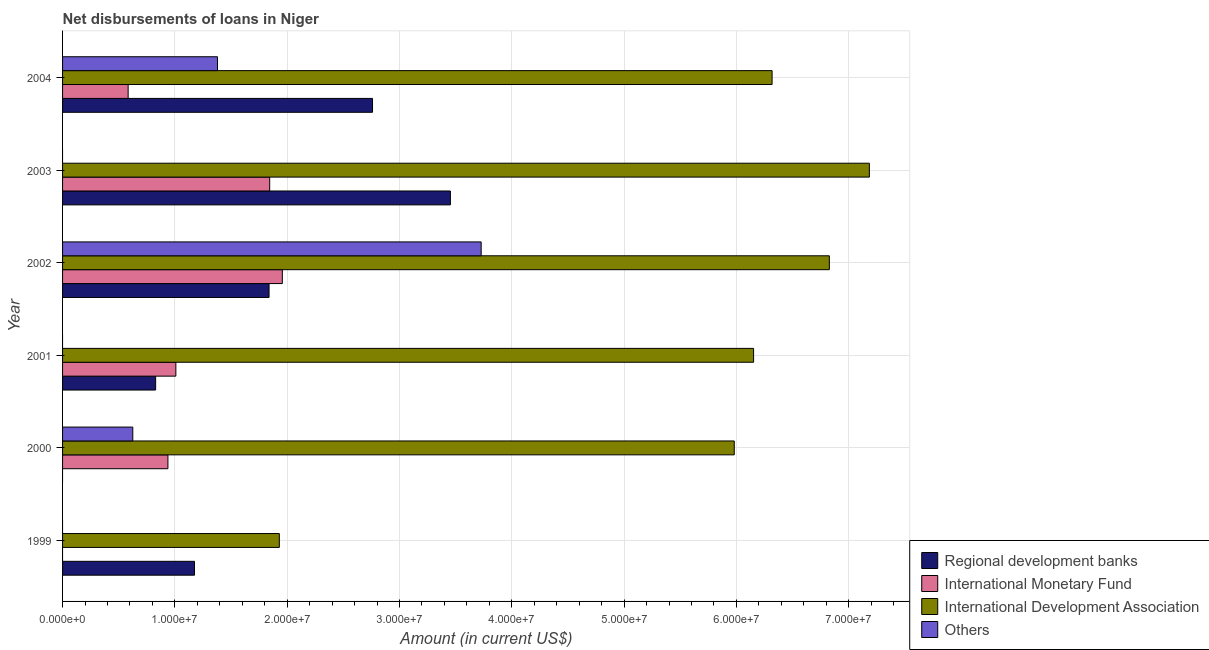How many different coloured bars are there?
Keep it short and to the point. 4. Are the number of bars on each tick of the Y-axis equal?
Your answer should be very brief. No. How many bars are there on the 2nd tick from the bottom?
Your answer should be compact. 3. What is the amount of loan disimbursed by regional development banks in 2004?
Offer a terse response. 2.76e+07. Across all years, what is the maximum amount of loan disimbursed by regional development banks?
Ensure brevity in your answer.  3.45e+07. Across all years, what is the minimum amount of loan disimbursed by regional development banks?
Provide a succinct answer. 0. What is the total amount of loan disimbursed by international development association in the graph?
Keep it short and to the point. 3.44e+08. What is the difference between the amount of loan disimbursed by international development association in 1999 and that in 2002?
Make the answer very short. -4.90e+07. What is the difference between the amount of loan disimbursed by regional development banks in 2000 and the amount of loan disimbursed by international development association in 2002?
Provide a succinct answer. -6.83e+07. What is the average amount of loan disimbursed by regional development banks per year?
Ensure brevity in your answer.  1.68e+07. In the year 2002, what is the difference between the amount of loan disimbursed by international monetary fund and amount of loan disimbursed by regional development banks?
Ensure brevity in your answer.  1.18e+06. What is the ratio of the amount of loan disimbursed by regional development banks in 2001 to that in 2002?
Your response must be concise. 0.45. Is the amount of loan disimbursed by regional development banks in 2001 less than that in 2003?
Offer a very short reply. Yes. What is the difference between the highest and the second highest amount of loan disimbursed by international monetary fund?
Your answer should be compact. 1.12e+06. What is the difference between the highest and the lowest amount of loan disimbursed by regional development banks?
Provide a succinct answer. 3.45e+07. Is it the case that in every year, the sum of the amount of loan disimbursed by international development association and amount of loan disimbursed by regional development banks is greater than the sum of amount of loan disimbursed by international monetary fund and amount of loan disimbursed by other organisations?
Keep it short and to the point. No. Is it the case that in every year, the sum of the amount of loan disimbursed by regional development banks and amount of loan disimbursed by international monetary fund is greater than the amount of loan disimbursed by international development association?
Your answer should be compact. No. How many years are there in the graph?
Offer a very short reply. 6. What is the difference between two consecutive major ticks on the X-axis?
Your response must be concise. 1.00e+07. Does the graph contain grids?
Offer a very short reply. Yes. Where does the legend appear in the graph?
Your response must be concise. Bottom right. How many legend labels are there?
Your response must be concise. 4. What is the title of the graph?
Your answer should be compact. Net disbursements of loans in Niger. Does "Third 20% of population" appear as one of the legend labels in the graph?
Keep it short and to the point. No. What is the label or title of the Y-axis?
Your answer should be very brief. Year. What is the Amount (in current US$) in Regional development banks in 1999?
Offer a very short reply. 1.17e+07. What is the Amount (in current US$) in International Development Association in 1999?
Provide a succinct answer. 1.93e+07. What is the Amount (in current US$) in Others in 1999?
Provide a succinct answer. 0. What is the Amount (in current US$) of Regional development banks in 2000?
Keep it short and to the point. 0. What is the Amount (in current US$) of International Monetary Fund in 2000?
Your response must be concise. 9.38e+06. What is the Amount (in current US$) of International Development Association in 2000?
Give a very brief answer. 5.98e+07. What is the Amount (in current US$) in Others in 2000?
Your answer should be compact. 6.25e+06. What is the Amount (in current US$) of Regional development banks in 2001?
Your answer should be very brief. 8.29e+06. What is the Amount (in current US$) of International Monetary Fund in 2001?
Your response must be concise. 1.01e+07. What is the Amount (in current US$) in International Development Association in 2001?
Offer a terse response. 6.15e+07. What is the Amount (in current US$) of Others in 2001?
Provide a short and direct response. 0. What is the Amount (in current US$) of Regional development banks in 2002?
Provide a short and direct response. 1.84e+07. What is the Amount (in current US$) in International Monetary Fund in 2002?
Your answer should be very brief. 1.96e+07. What is the Amount (in current US$) in International Development Association in 2002?
Offer a terse response. 6.83e+07. What is the Amount (in current US$) in Others in 2002?
Your answer should be compact. 3.73e+07. What is the Amount (in current US$) in Regional development banks in 2003?
Your response must be concise. 3.45e+07. What is the Amount (in current US$) of International Monetary Fund in 2003?
Your response must be concise. 1.84e+07. What is the Amount (in current US$) in International Development Association in 2003?
Give a very brief answer. 7.18e+07. What is the Amount (in current US$) in Regional development banks in 2004?
Offer a very short reply. 2.76e+07. What is the Amount (in current US$) of International Monetary Fund in 2004?
Offer a terse response. 5.84e+06. What is the Amount (in current US$) of International Development Association in 2004?
Provide a short and direct response. 6.32e+07. What is the Amount (in current US$) in Others in 2004?
Provide a succinct answer. 1.38e+07. Across all years, what is the maximum Amount (in current US$) in Regional development banks?
Make the answer very short. 3.45e+07. Across all years, what is the maximum Amount (in current US$) of International Monetary Fund?
Provide a succinct answer. 1.96e+07. Across all years, what is the maximum Amount (in current US$) of International Development Association?
Offer a very short reply. 7.18e+07. Across all years, what is the maximum Amount (in current US$) in Others?
Ensure brevity in your answer.  3.73e+07. Across all years, what is the minimum Amount (in current US$) of Regional development banks?
Give a very brief answer. 0. Across all years, what is the minimum Amount (in current US$) in International Development Association?
Ensure brevity in your answer.  1.93e+07. Across all years, what is the minimum Amount (in current US$) of Others?
Provide a short and direct response. 0. What is the total Amount (in current US$) of Regional development banks in the graph?
Offer a very short reply. 1.01e+08. What is the total Amount (in current US$) of International Monetary Fund in the graph?
Your answer should be very brief. 6.33e+07. What is the total Amount (in current US$) in International Development Association in the graph?
Provide a short and direct response. 3.44e+08. What is the total Amount (in current US$) in Others in the graph?
Your answer should be very brief. 5.73e+07. What is the difference between the Amount (in current US$) in International Development Association in 1999 and that in 2000?
Ensure brevity in your answer.  -4.05e+07. What is the difference between the Amount (in current US$) in Regional development banks in 1999 and that in 2001?
Give a very brief answer. 3.46e+06. What is the difference between the Amount (in current US$) in International Development Association in 1999 and that in 2001?
Your answer should be compact. -4.22e+07. What is the difference between the Amount (in current US$) in Regional development banks in 1999 and that in 2002?
Your answer should be very brief. -6.64e+06. What is the difference between the Amount (in current US$) in International Development Association in 1999 and that in 2002?
Your answer should be very brief. -4.90e+07. What is the difference between the Amount (in current US$) of Regional development banks in 1999 and that in 2003?
Make the answer very short. -2.28e+07. What is the difference between the Amount (in current US$) in International Development Association in 1999 and that in 2003?
Offer a very short reply. -5.25e+07. What is the difference between the Amount (in current US$) of Regional development banks in 1999 and that in 2004?
Your response must be concise. -1.58e+07. What is the difference between the Amount (in current US$) of International Development Association in 1999 and that in 2004?
Make the answer very short. -4.39e+07. What is the difference between the Amount (in current US$) of International Monetary Fund in 2000 and that in 2001?
Your answer should be compact. -7.07e+05. What is the difference between the Amount (in current US$) of International Development Association in 2000 and that in 2001?
Give a very brief answer. -1.72e+06. What is the difference between the Amount (in current US$) of International Monetary Fund in 2000 and that in 2002?
Your response must be concise. -1.02e+07. What is the difference between the Amount (in current US$) in International Development Association in 2000 and that in 2002?
Offer a very short reply. -8.47e+06. What is the difference between the Amount (in current US$) in Others in 2000 and that in 2002?
Your answer should be very brief. -3.10e+07. What is the difference between the Amount (in current US$) of International Monetary Fund in 2000 and that in 2003?
Provide a short and direct response. -9.06e+06. What is the difference between the Amount (in current US$) of International Development Association in 2000 and that in 2003?
Your answer should be very brief. -1.20e+07. What is the difference between the Amount (in current US$) in International Monetary Fund in 2000 and that in 2004?
Keep it short and to the point. 3.54e+06. What is the difference between the Amount (in current US$) of International Development Association in 2000 and that in 2004?
Provide a short and direct response. -3.37e+06. What is the difference between the Amount (in current US$) in Others in 2000 and that in 2004?
Offer a terse response. -7.54e+06. What is the difference between the Amount (in current US$) of Regional development banks in 2001 and that in 2002?
Provide a short and direct response. -1.01e+07. What is the difference between the Amount (in current US$) in International Monetary Fund in 2001 and that in 2002?
Offer a very short reply. -9.48e+06. What is the difference between the Amount (in current US$) in International Development Association in 2001 and that in 2002?
Your answer should be very brief. -6.75e+06. What is the difference between the Amount (in current US$) of Regional development banks in 2001 and that in 2003?
Your answer should be very brief. -2.62e+07. What is the difference between the Amount (in current US$) of International Monetary Fund in 2001 and that in 2003?
Offer a very short reply. -8.36e+06. What is the difference between the Amount (in current US$) of International Development Association in 2001 and that in 2003?
Keep it short and to the point. -1.03e+07. What is the difference between the Amount (in current US$) of Regional development banks in 2001 and that in 2004?
Your response must be concise. -1.93e+07. What is the difference between the Amount (in current US$) in International Monetary Fund in 2001 and that in 2004?
Provide a short and direct response. 4.25e+06. What is the difference between the Amount (in current US$) of International Development Association in 2001 and that in 2004?
Your response must be concise. -1.65e+06. What is the difference between the Amount (in current US$) in Regional development banks in 2002 and that in 2003?
Your answer should be very brief. -1.61e+07. What is the difference between the Amount (in current US$) in International Monetary Fund in 2002 and that in 2003?
Offer a very short reply. 1.12e+06. What is the difference between the Amount (in current US$) in International Development Association in 2002 and that in 2003?
Offer a very short reply. -3.56e+06. What is the difference between the Amount (in current US$) of Regional development banks in 2002 and that in 2004?
Offer a very short reply. -9.21e+06. What is the difference between the Amount (in current US$) in International Monetary Fund in 2002 and that in 2004?
Ensure brevity in your answer.  1.37e+07. What is the difference between the Amount (in current US$) in International Development Association in 2002 and that in 2004?
Give a very brief answer. 5.10e+06. What is the difference between the Amount (in current US$) in Others in 2002 and that in 2004?
Give a very brief answer. 2.35e+07. What is the difference between the Amount (in current US$) of Regional development banks in 2003 and that in 2004?
Your answer should be compact. 6.94e+06. What is the difference between the Amount (in current US$) of International Monetary Fund in 2003 and that in 2004?
Provide a short and direct response. 1.26e+07. What is the difference between the Amount (in current US$) in International Development Association in 2003 and that in 2004?
Offer a very short reply. 8.66e+06. What is the difference between the Amount (in current US$) of Regional development banks in 1999 and the Amount (in current US$) of International Monetary Fund in 2000?
Keep it short and to the point. 2.37e+06. What is the difference between the Amount (in current US$) of Regional development banks in 1999 and the Amount (in current US$) of International Development Association in 2000?
Ensure brevity in your answer.  -4.81e+07. What is the difference between the Amount (in current US$) of Regional development banks in 1999 and the Amount (in current US$) of Others in 2000?
Offer a very short reply. 5.50e+06. What is the difference between the Amount (in current US$) of International Development Association in 1999 and the Amount (in current US$) of Others in 2000?
Offer a very short reply. 1.30e+07. What is the difference between the Amount (in current US$) in Regional development banks in 1999 and the Amount (in current US$) in International Monetary Fund in 2001?
Ensure brevity in your answer.  1.66e+06. What is the difference between the Amount (in current US$) in Regional development banks in 1999 and the Amount (in current US$) in International Development Association in 2001?
Your response must be concise. -4.98e+07. What is the difference between the Amount (in current US$) in Regional development banks in 1999 and the Amount (in current US$) in International Monetary Fund in 2002?
Give a very brief answer. -7.82e+06. What is the difference between the Amount (in current US$) of Regional development banks in 1999 and the Amount (in current US$) of International Development Association in 2002?
Give a very brief answer. -5.65e+07. What is the difference between the Amount (in current US$) in Regional development banks in 1999 and the Amount (in current US$) in Others in 2002?
Provide a short and direct response. -2.55e+07. What is the difference between the Amount (in current US$) of International Development Association in 1999 and the Amount (in current US$) of Others in 2002?
Give a very brief answer. -1.80e+07. What is the difference between the Amount (in current US$) of Regional development banks in 1999 and the Amount (in current US$) of International Monetary Fund in 2003?
Offer a terse response. -6.70e+06. What is the difference between the Amount (in current US$) of Regional development banks in 1999 and the Amount (in current US$) of International Development Association in 2003?
Ensure brevity in your answer.  -6.01e+07. What is the difference between the Amount (in current US$) of Regional development banks in 1999 and the Amount (in current US$) of International Monetary Fund in 2004?
Keep it short and to the point. 5.91e+06. What is the difference between the Amount (in current US$) in Regional development banks in 1999 and the Amount (in current US$) in International Development Association in 2004?
Provide a succinct answer. -5.14e+07. What is the difference between the Amount (in current US$) of Regional development banks in 1999 and the Amount (in current US$) of Others in 2004?
Offer a very short reply. -2.05e+06. What is the difference between the Amount (in current US$) of International Development Association in 1999 and the Amount (in current US$) of Others in 2004?
Your answer should be compact. 5.50e+06. What is the difference between the Amount (in current US$) in International Monetary Fund in 2000 and the Amount (in current US$) in International Development Association in 2001?
Provide a short and direct response. -5.21e+07. What is the difference between the Amount (in current US$) in International Monetary Fund in 2000 and the Amount (in current US$) in International Development Association in 2002?
Provide a short and direct response. -5.89e+07. What is the difference between the Amount (in current US$) of International Monetary Fund in 2000 and the Amount (in current US$) of Others in 2002?
Make the answer very short. -2.79e+07. What is the difference between the Amount (in current US$) in International Development Association in 2000 and the Amount (in current US$) in Others in 2002?
Offer a terse response. 2.25e+07. What is the difference between the Amount (in current US$) in International Monetary Fund in 2000 and the Amount (in current US$) in International Development Association in 2003?
Make the answer very short. -6.25e+07. What is the difference between the Amount (in current US$) of International Monetary Fund in 2000 and the Amount (in current US$) of International Development Association in 2004?
Ensure brevity in your answer.  -5.38e+07. What is the difference between the Amount (in current US$) in International Monetary Fund in 2000 and the Amount (in current US$) in Others in 2004?
Provide a succinct answer. -4.42e+06. What is the difference between the Amount (in current US$) in International Development Association in 2000 and the Amount (in current US$) in Others in 2004?
Provide a succinct answer. 4.60e+07. What is the difference between the Amount (in current US$) in Regional development banks in 2001 and the Amount (in current US$) in International Monetary Fund in 2002?
Keep it short and to the point. -1.13e+07. What is the difference between the Amount (in current US$) of Regional development banks in 2001 and the Amount (in current US$) of International Development Association in 2002?
Provide a succinct answer. -6.00e+07. What is the difference between the Amount (in current US$) in Regional development banks in 2001 and the Amount (in current US$) in Others in 2002?
Provide a short and direct response. -2.90e+07. What is the difference between the Amount (in current US$) in International Monetary Fund in 2001 and the Amount (in current US$) in International Development Association in 2002?
Offer a terse response. -5.82e+07. What is the difference between the Amount (in current US$) of International Monetary Fund in 2001 and the Amount (in current US$) of Others in 2002?
Make the answer very short. -2.72e+07. What is the difference between the Amount (in current US$) in International Development Association in 2001 and the Amount (in current US$) in Others in 2002?
Provide a short and direct response. 2.43e+07. What is the difference between the Amount (in current US$) in Regional development banks in 2001 and the Amount (in current US$) in International Monetary Fund in 2003?
Give a very brief answer. -1.02e+07. What is the difference between the Amount (in current US$) in Regional development banks in 2001 and the Amount (in current US$) in International Development Association in 2003?
Make the answer very short. -6.36e+07. What is the difference between the Amount (in current US$) of International Monetary Fund in 2001 and the Amount (in current US$) of International Development Association in 2003?
Offer a very short reply. -6.18e+07. What is the difference between the Amount (in current US$) of Regional development banks in 2001 and the Amount (in current US$) of International Monetary Fund in 2004?
Your answer should be very brief. 2.45e+06. What is the difference between the Amount (in current US$) of Regional development banks in 2001 and the Amount (in current US$) of International Development Association in 2004?
Your answer should be compact. -5.49e+07. What is the difference between the Amount (in current US$) in Regional development banks in 2001 and the Amount (in current US$) in Others in 2004?
Give a very brief answer. -5.51e+06. What is the difference between the Amount (in current US$) in International Monetary Fund in 2001 and the Amount (in current US$) in International Development Association in 2004?
Make the answer very short. -5.31e+07. What is the difference between the Amount (in current US$) of International Monetary Fund in 2001 and the Amount (in current US$) of Others in 2004?
Provide a short and direct response. -3.71e+06. What is the difference between the Amount (in current US$) of International Development Association in 2001 and the Amount (in current US$) of Others in 2004?
Provide a succinct answer. 4.77e+07. What is the difference between the Amount (in current US$) of Regional development banks in 2002 and the Amount (in current US$) of International Monetary Fund in 2003?
Give a very brief answer. -5.60e+04. What is the difference between the Amount (in current US$) in Regional development banks in 2002 and the Amount (in current US$) in International Development Association in 2003?
Your answer should be compact. -5.35e+07. What is the difference between the Amount (in current US$) of International Monetary Fund in 2002 and the Amount (in current US$) of International Development Association in 2003?
Your answer should be compact. -5.23e+07. What is the difference between the Amount (in current US$) in Regional development banks in 2002 and the Amount (in current US$) in International Monetary Fund in 2004?
Offer a very short reply. 1.25e+07. What is the difference between the Amount (in current US$) in Regional development banks in 2002 and the Amount (in current US$) in International Development Association in 2004?
Your response must be concise. -4.48e+07. What is the difference between the Amount (in current US$) of Regional development banks in 2002 and the Amount (in current US$) of Others in 2004?
Make the answer very short. 4.59e+06. What is the difference between the Amount (in current US$) of International Monetary Fund in 2002 and the Amount (in current US$) of International Development Association in 2004?
Your answer should be very brief. -4.36e+07. What is the difference between the Amount (in current US$) in International Monetary Fund in 2002 and the Amount (in current US$) in Others in 2004?
Ensure brevity in your answer.  5.77e+06. What is the difference between the Amount (in current US$) in International Development Association in 2002 and the Amount (in current US$) in Others in 2004?
Make the answer very short. 5.45e+07. What is the difference between the Amount (in current US$) of Regional development banks in 2003 and the Amount (in current US$) of International Monetary Fund in 2004?
Offer a very short reply. 2.87e+07. What is the difference between the Amount (in current US$) in Regional development banks in 2003 and the Amount (in current US$) in International Development Association in 2004?
Your answer should be very brief. -2.86e+07. What is the difference between the Amount (in current US$) in Regional development banks in 2003 and the Amount (in current US$) in Others in 2004?
Provide a short and direct response. 2.07e+07. What is the difference between the Amount (in current US$) of International Monetary Fund in 2003 and the Amount (in current US$) of International Development Association in 2004?
Give a very brief answer. -4.47e+07. What is the difference between the Amount (in current US$) of International Monetary Fund in 2003 and the Amount (in current US$) of Others in 2004?
Offer a very short reply. 4.65e+06. What is the difference between the Amount (in current US$) in International Development Association in 2003 and the Amount (in current US$) in Others in 2004?
Your answer should be compact. 5.80e+07. What is the average Amount (in current US$) of Regional development banks per year?
Your answer should be very brief. 1.68e+07. What is the average Amount (in current US$) of International Monetary Fund per year?
Your answer should be compact. 1.06e+07. What is the average Amount (in current US$) of International Development Association per year?
Your answer should be very brief. 5.73e+07. What is the average Amount (in current US$) of Others per year?
Your response must be concise. 9.55e+06. In the year 1999, what is the difference between the Amount (in current US$) in Regional development banks and Amount (in current US$) in International Development Association?
Provide a succinct answer. -7.55e+06. In the year 2000, what is the difference between the Amount (in current US$) in International Monetary Fund and Amount (in current US$) in International Development Association?
Your response must be concise. -5.04e+07. In the year 2000, what is the difference between the Amount (in current US$) of International Monetary Fund and Amount (in current US$) of Others?
Your answer should be compact. 3.13e+06. In the year 2000, what is the difference between the Amount (in current US$) in International Development Association and Amount (in current US$) in Others?
Make the answer very short. 5.36e+07. In the year 2001, what is the difference between the Amount (in current US$) in Regional development banks and Amount (in current US$) in International Monetary Fund?
Keep it short and to the point. -1.80e+06. In the year 2001, what is the difference between the Amount (in current US$) of Regional development banks and Amount (in current US$) of International Development Association?
Your answer should be very brief. -5.32e+07. In the year 2001, what is the difference between the Amount (in current US$) in International Monetary Fund and Amount (in current US$) in International Development Association?
Ensure brevity in your answer.  -5.14e+07. In the year 2002, what is the difference between the Amount (in current US$) of Regional development banks and Amount (in current US$) of International Monetary Fund?
Your answer should be compact. -1.18e+06. In the year 2002, what is the difference between the Amount (in current US$) in Regional development banks and Amount (in current US$) in International Development Association?
Ensure brevity in your answer.  -4.99e+07. In the year 2002, what is the difference between the Amount (in current US$) in Regional development banks and Amount (in current US$) in Others?
Provide a succinct answer. -1.89e+07. In the year 2002, what is the difference between the Amount (in current US$) of International Monetary Fund and Amount (in current US$) of International Development Association?
Provide a short and direct response. -4.87e+07. In the year 2002, what is the difference between the Amount (in current US$) in International Monetary Fund and Amount (in current US$) in Others?
Keep it short and to the point. -1.77e+07. In the year 2002, what is the difference between the Amount (in current US$) in International Development Association and Amount (in current US$) in Others?
Make the answer very short. 3.10e+07. In the year 2003, what is the difference between the Amount (in current US$) in Regional development banks and Amount (in current US$) in International Monetary Fund?
Keep it short and to the point. 1.61e+07. In the year 2003, what is the difference between the Amount (in current US$) of Regional development banks and Amount (in current US$) of International Development Association?
Offer a very short reply. -3.73e+07. In the year 2003, what is the difference between the Amount (in current US$) in International Monetary Fund and Amount (in current US$) in International Development Association?
Your answer should be very brief. -5.34e+07. In the year 2004, what is the difference between the Amount (in current US$) of Regional development banks and Amount (in current US$) of International Monetary Fund?
Make the answer very short. 2.18e+07. In the year 2004, what is the difference between the Amount (in current US$) in Regional development banks and Amount (in current US$) in International Development Association?
Provide a short and direct response. -3.56e+07. In the year 2004, what is the difference between the Amount (in current US$) of Regional development banks and Amount (in current US$) of Others?
Make the answer very short. 1.38e+07. In the year 2004, what is the difference between the Amount (in current US$) in International Monetary Fund and Amount (in current US$) in International Development Association?
Make the answer very short. -5.73e+07. In the year 2004, what is the difference between the Amount (in current US$) in International Monetary Fund and Amount (in current US$) in Others?
Ensure brevity in your answer.  -7.96e+06. In the year 2004, what is the difference between the Amount (in current US$) of International Development Association and Amount (in current US$) of Others?
Provide a succinct answer. 4.94e+07. What is the ratio of the Amount (in current US$) of International Development Association in 1999 to that in 2000?
Ensure brevity in your answer.  0.32. What is the ratio of the Amount (in current US$) in Regional development banks in 1999 to that in 2001?
Make the answer very short. 1.42. What is the ratio of the Amount (in current US$) in International Development Association in 1999 to that in 2001?
Give a very brief answer. 0.31. What is the ratio of the Amount (in current US$) in Regional development banks in 1999 to that in 2002?
Ensure brevity in your answer.  0.64. What is the ratio of the Amount (in current US$) of International Development Association in 1999 to that in 2002?
Keep it short and to the point. 0.28. What is the ratio of the Amount (in current US$) of Regional development banks in 1999 to that in 2003?
Provide a succinct answer. 0.34. What is the ratio of the Amount (in current US$) in International Development Association in 1999 to that in 2003?
Your response must be concise. 0.27. What is the ratio of the Amount (in current US$) of Regional development banks in 1999 to that in 2004?
Provide a short and direct response. 0.43. What is the ratio of the Amount (in current US$) of International Development Association in 1999 to that in 2004?
Your answer should be compact. 0.31. What is the ratio of the Amount (in current US$) of International Monetary Fund in 2000 to that in 2001?
Make the answer very short. 0.93. What is the ratio of the Amount (in current US$) of International Monetary Fund in 2000 to that in 2002?
Make the answer very short. 0.48. What is the ratio of the Amount (in current US$) of International Development Association in 2000 to that in 2002?
Provide a short and direct response. 0.88. What is the ratio of the Amount (in current US$) of Others in 2000 to that in 2002?
Ensure brevity in your answer.  0.17. What is the ratio of the Amount (in current US$) in International Monetary Fund in 2000 to that in 2003?
Provide a short and direct response. 0.51. What is the ratio of the Amount (in current US$) in International Development Association in 2000 to that in 2003?
Ensure brevity in your answer.  0.83. What is the ratio of the Amount (in current US$) in International Monetary Fund in 2000 to that in 2004?
Offer a terse response. 1.61. What is the ratio of the Amount (in current US$) in International Development Association in 2000 to that in 2004?
Keep it short and to the point. 0.95. What is the ratio of the Amount (in current US$) of Others in 2000 to that in 2004?
Your answer should be compact. 0.45. What is the ratio of the Amount (in current US$) of Regional development banks in 2001 to that in 2002?
Your answer should be very brief. 0.45. What is the ratio of the Amount (in current US$) in International Monetary Fund in 2001 to that in 2002?
Make the answer very short. 0.52. What is the ratio of the Amount (in current US$) in International Development Association in 2001 to that in 2002?
Your response must be concise. 0.9. What is the ratio of the Amount (in current US$) of Regional development banks in 2001 to that in 2003?
Your answer should be compact. 0.24. What is the ratio of the Amount (in current US$) in International Monetary Fund in 2001 to that in 2003?
Your response must be concise. 0.55. What is the ratio of the Amount (in current US$) of International Development Association in 2001 to that in 2003?
Offer a terse response. 0.86. What is the ratio of the Amount (in current US$) of Regional development banks in 2001 to that in 2004?
Offer a very short reply. 0.3. What is the ratio of the Amount (in current US$) of International Monetary Fund in 2001 to that in 2004?
Provide a succinct answer. 1.73. What is the ratio of the Amount (in current US$) of International Development Association in 2001 to that in 2004?
Make the answer very short. 0.97. What is the ratio of the Amount (in current US$) in Regional development banks in 2002 to that in 2003?
Make the answer very short. 0.53. What is the ratio of the Amount (in current US$) of International Monetary Fund in 2002 to that in 2003?
Offer a terse response. 1.06. What is the ratio of the Amount (in current US$) of International Development Association in 2002 to that in 2003?
Provide a short and direct response. 0.95. What is the ratio of the Amount (in current US$) of Regional development banks in 2002 to that in 2004?
Make the answer very short. 0.67. What is the ratio of the Amount (in current US$) in International Monetary Fund in 2002 to that in 2004?
Provide a short and direct response. 3.35. What is the ratio of the Amount (in current US$) of International Development Association in 2002 to that in 2004?
Give a very brief answer. 1.08. What is the ratio of the Amount (in current US$) in Others in 2002 to that in 2004?
Give a very brief answer. 2.7. What is the ratio of the Amount (in current US$) of Regional development banks in 2003 to that in 2004?
Provide a succinct answer. 1.25. What is the ratio of the Amount (in current US$) in International Monetary Fund in 2003 to that in 2004?
Provide a short and direct response. 3.16. What is the ratio of the Amount (in current US$) in International Development Association in 2003 to that in 2004?
Your answer should be very brief. 1.14. What is the difference between the highest and the second highest Amount (in current US$) in Regional development banks?
Make the answer very short. 6.94e+06. What is the difference between the highest and the second highest Amount (in current US$) of International Monetary Fund?
Provide a succinct answer. 1.12e+06. What is the difference between the highest and the second highest Amount (in current US$) in International Development Association?
Ensure brevity in your answer.  3.56e+06. What is the difference between the highest and the second highest Amount (in current US$) in Others?
Offer a terse response. 2.35e+07. What is the difference between the highest and the lowest Amount (in current US$) in Regional development banks?
Offer a terse response. 3.45e+07. What is the difference between the highest and the lowest Amount (in current US$) of International Monetary Fund?
Provide a succinct answer. 1.96e+07. What is the difference between the highest and the lowest Amount (in current US$) in International Development Association?
Ensure brevity in your answer.  5.25e+07. What is the difference between the highest and the lowest Amount (in current US$) in Others?
Offer a very short reply. 3.73e+07. 